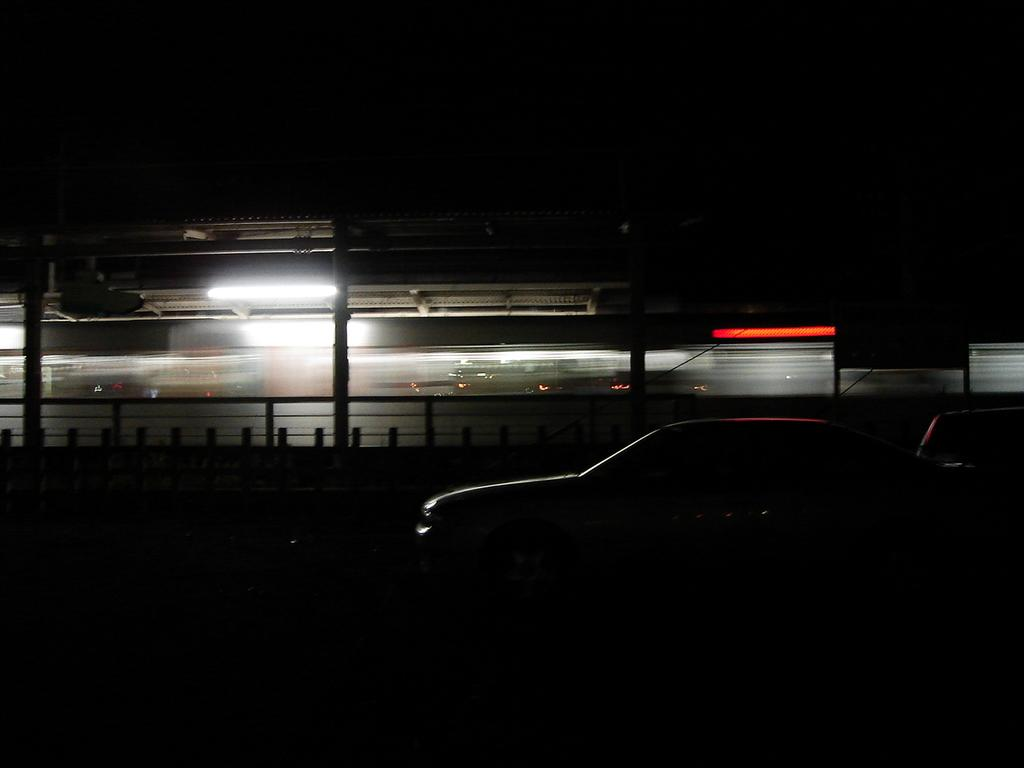What type of vehicle is located at the bottom of the image? There is a car at the bottom of the image. What other mode of transportation can be seen in the image? There appears to be a train in the middle of the image. What structure is also present in the middle of the image? There is a shelter in the middle of the image. What can be observed about the lighting in the image? The top of the image is dark. How many snails can be seen distributing goods in the image? There are no snails present in the image, and they are not distributing goods. What type of trees are growing near the shelter in the image? There is no mention of trees in the image, so we cannot determine what type of trees might be growing near the shelter. 